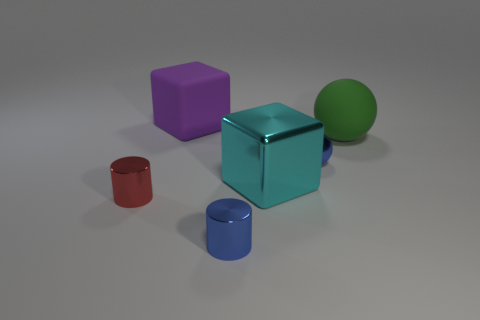Add 3 large green metallic cylinders. How many objects exist? 9 Subtract all cylinders. How many objects are left? 4 Add 5 cyan matte cylinders. How many cyan matte cylinders exist? 5 Subtract 1 blue spheres. How many objects are left? 5 Subtract all tiny shiny cylinders. Subtract all small cyan cylinders. How many objects are left? 4 Add 1 blue metal objects. How many blue metal objects are left? 3 